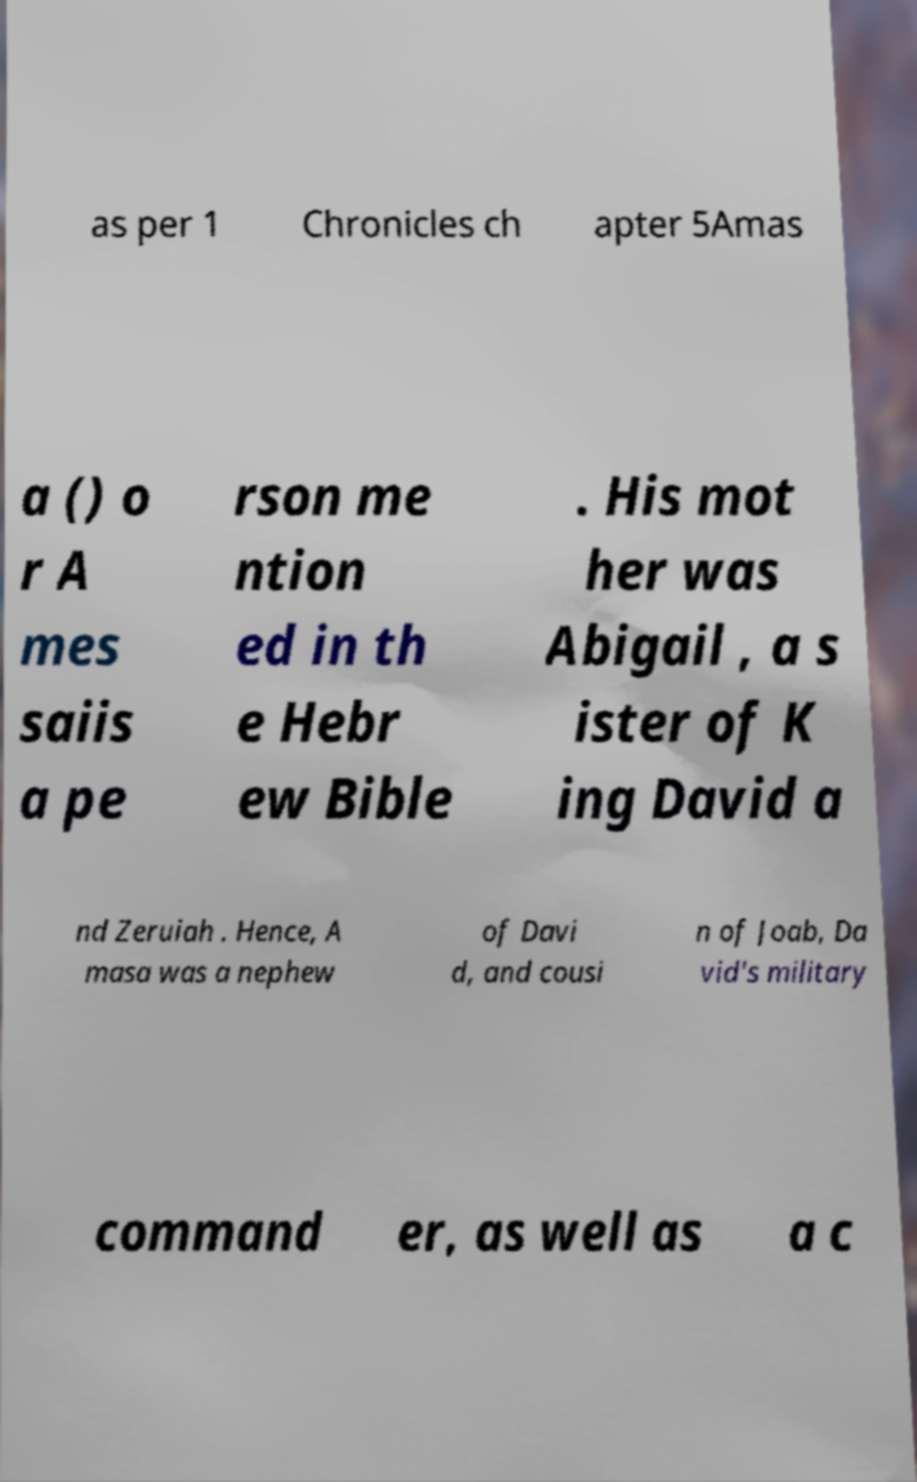Can you read and provide the text displayed in the image?This photo seems to have some interesting text. Can you extract and type it out for me? as per 1 Chronicles ch apter 5Amas a () o r A mes saiis a pe rson me ntion ed in th e Hebr ew Bible . His mot her was Abigail , a s ister of K ing David a nd Zeruiah . Hence, A masa was a nephew of Davi d, and cousi n of Joab, Da vid's military command er, as well as a c 